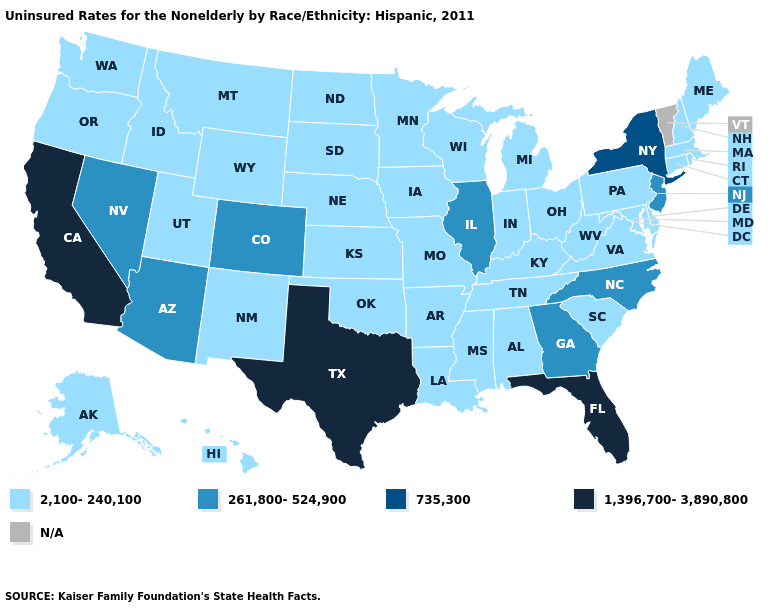Does Illinois have the highest value in the MidWest?
Keep it brief. Yes. What is the value of Iowa?
Short answer required. 2,100-240,100. Which states hav the highest value in the West?
Write a very short answer. California. Which states have the lowest value in the Northeast?
Be succinct. Connecticut, Maine, Massachusetts, New Hampshire, Pennsylvania, Rhode Island. What is the value of Oregon?
Keep it brief. 2,100-240,100. Name the states that have a value in the range 261,800-524,900?
Give a very brief answer. Arizona, Colorado, Georgia, Illinois, Nevada, New Jersey, North Carolina. Name the states that have a value in the range N/A?
Keep it brief. Vermont. Is the legend a continuous bar?
Be succinct. No. Which states have the highest value in the USA?
Be succinct. California, Florida, Texas. Does Florida have the highest value in the South?
Be succinct. Yes. Does Nevada have the highest value in the West?
Be succinct. No. Among the states that border Colorado , does Utah have the highest value?
Answer briefly. No. Which states have the highest value in the USA?
Answer briefly. California, Florida, Texas. What is the value of Minnesota?
Keep it brief. 2,100-240,100. Is the legend a continuous bar?
Answer briefly. No. 